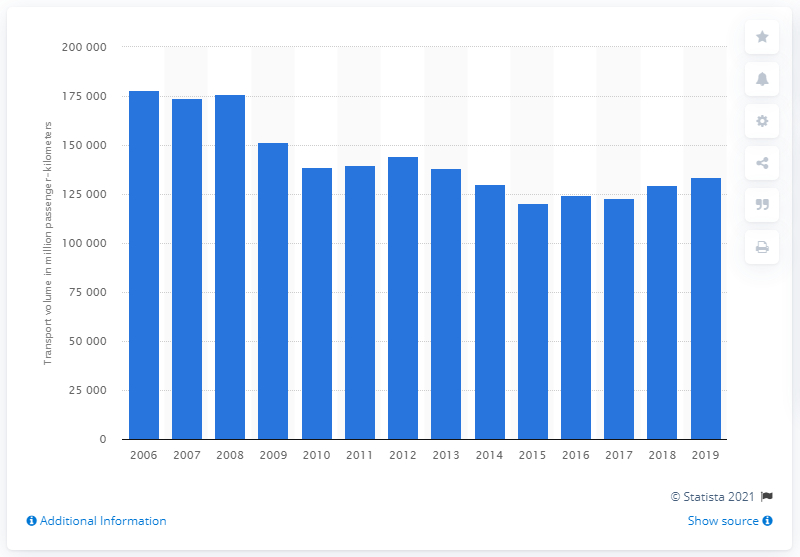Outline some significant characteristics in this image. In 2018, the volume of passenger rail transport in Russia was 133,589. In 2015, the volume of passenger rail transport in Russia was the lowest at 120,644. 